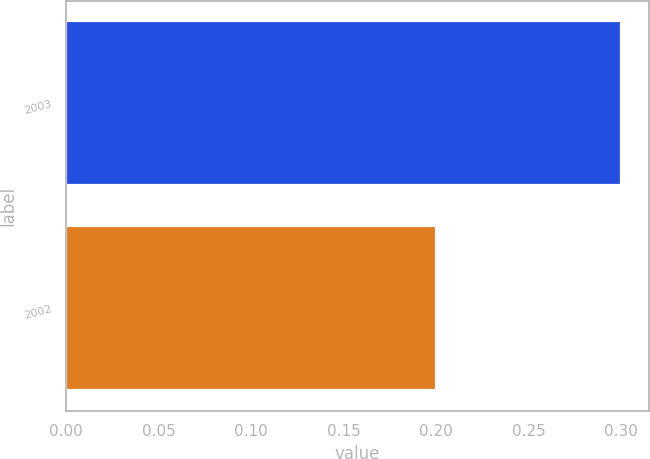<chart> <loc_0><loc_0><loc_500><loc_500><bar_chart><fcel>2003<fcel>2002<nl><fcel>0.3<fcel>0.2<nl></chart> 